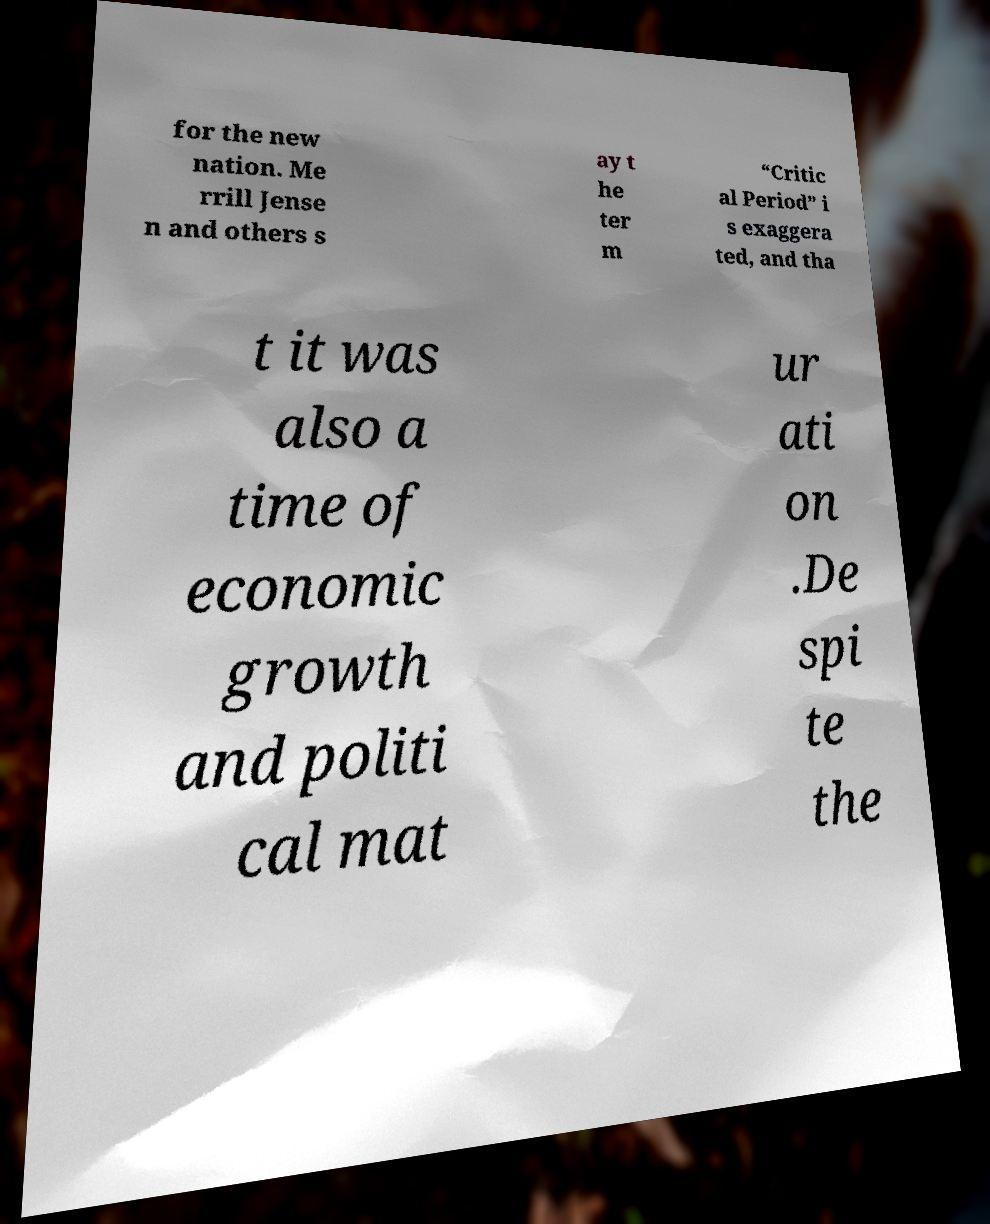For documentation purposes, I need the text within this image transcribed. Could you provide that? for the new nation. Me rrill Jense n and others s ay t he ter m “Critic al Period” i s exaggera ted, and tha t it was also a time of economic growth and politi cal mat ur ati on .De spi te the 